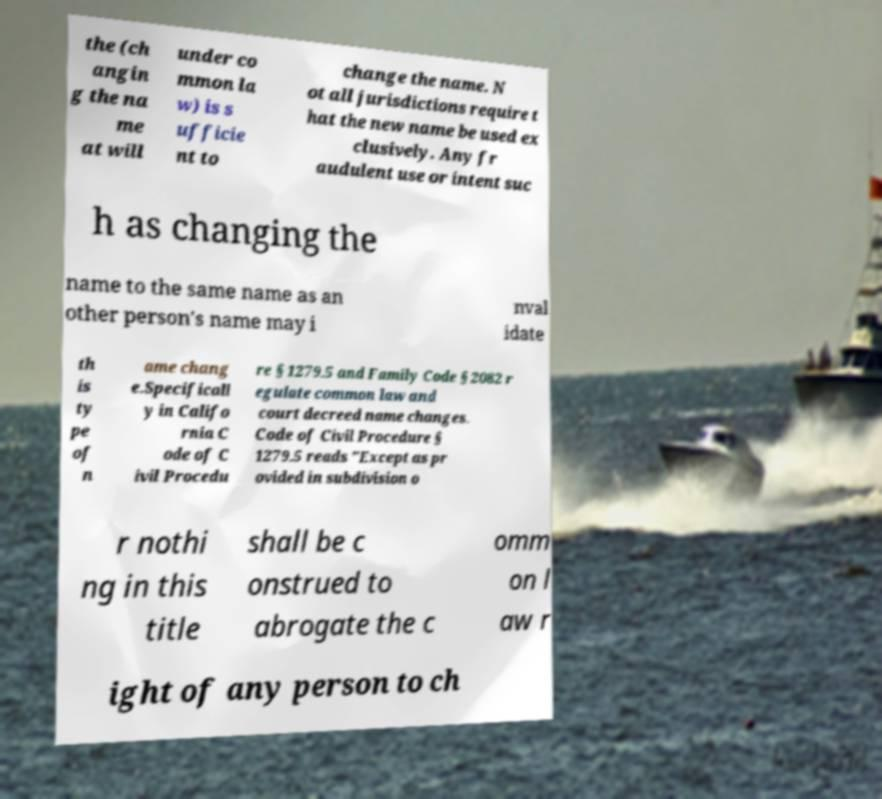Please identify and transcribe the text found in this image. the (ch angin g the na me at will under co mmon la w) is s ufficie nt to change the name. N ot all jurisdictions require t hat the new name be used ex clusively. Any fr audulent use or intent suc h as changing the name to the same name as an other person's name may i nval idate th is ty pe of n ame chang e.Specificall y in Califo rnia C ode of C ivil Procedu re § 1279.5 and Family Code § 2082 r egulate common law and court decreed name changes. Code of Civil Procedure § 1279.5 reads "Except as pr ovided in subdivision o r nothi ng in this title shall be c onstrued to abrogate the c omm on l aw r ight of any person to ch 